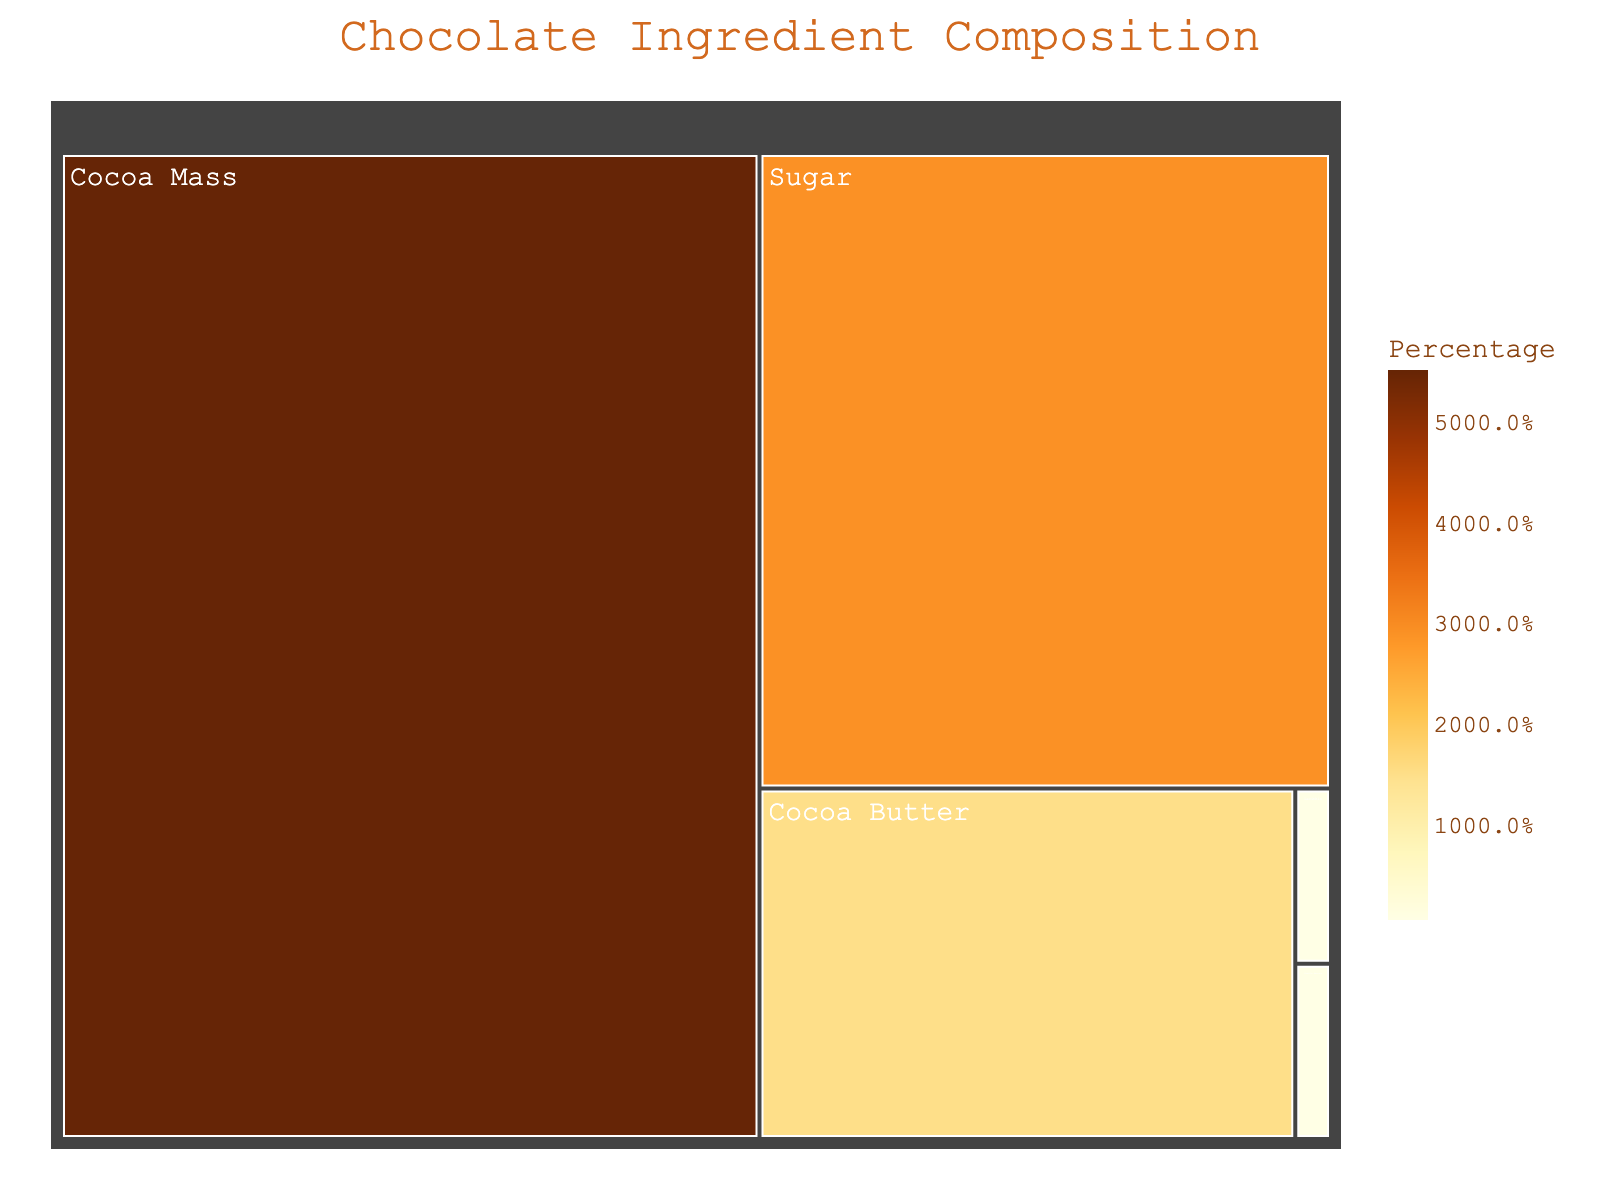what is the title of the figure? The title of the figure is often prominently placed at the top. In this case, the title is found in the code and displays exactly as "Chocolate Ingredient Composition".
Answer: Chocolate Ingredient Composition What ingredient has the highest percentage in the chocolate composition? The largest area in a treemap with the corresponding percentage value is typically the highest percentage. "Cocoa Mass" is the largest with 55%.
Answer: Cocoa Mass How much more percentage does Cocoa Mass have than Sugar? Subtract the percentage of Sugar from Cocoa Mass: 55% - 29% which equals 26%.
Answer: 26% Which ingredient appears to have equal percentages? Ingredients with the same area and percentage value are equal. Both "Vanilla Extract" and "Lecithin" have 0.5%.
Answer: Vanilla Extract and Lecithin What is the second most abundant ingredient in the chocolate composition? The second largest area after Cocoa Mass is "Sugar" with 29%.
Answer: Sugar What percentage of the chocolate is contributed by Vanilla Extract and Lecithin combined? Add the percentages of Vanilla Extract and Lecithin: 0.5% + 0.5% which equals 1%.
Answer: 1% Is there more Cocoa Butter or Sugar in the composition? Compare the percentages of Cocoa Butter and Sugar: "Sugar" with 29% is greater than "Cocoa Butter" with 15%.
Answer: Sugar What is the range of percentages in the chocolate ingredient composition? The range is found by subtracting the smallest percentage from the largest. Largest is Cocoa Mass (55%), smallest is either Vanilla Extract or Lecithin (0.5%). So, 55% - 0.5% = 54.5%.
Answer: 54.5% What percentage of the composition do Cocoa-related ingredients (Cocoa Mass + Cocoa Butter) contribute? Add the percentages of Cocoa Mass and Cocoa Butter: 55% + 15% which equals 70%.
Answer: 70% What is the percentage difference between Cocoa Butter and the combined total of Vanilla Extract and Lecithin? Subtract the combined percentage of Vanilla Extract and Lecithin from Cocoa Butter: 15% - (0.5% + 0.5%) = 15% - 1% = 14%.
Answer: 14% 